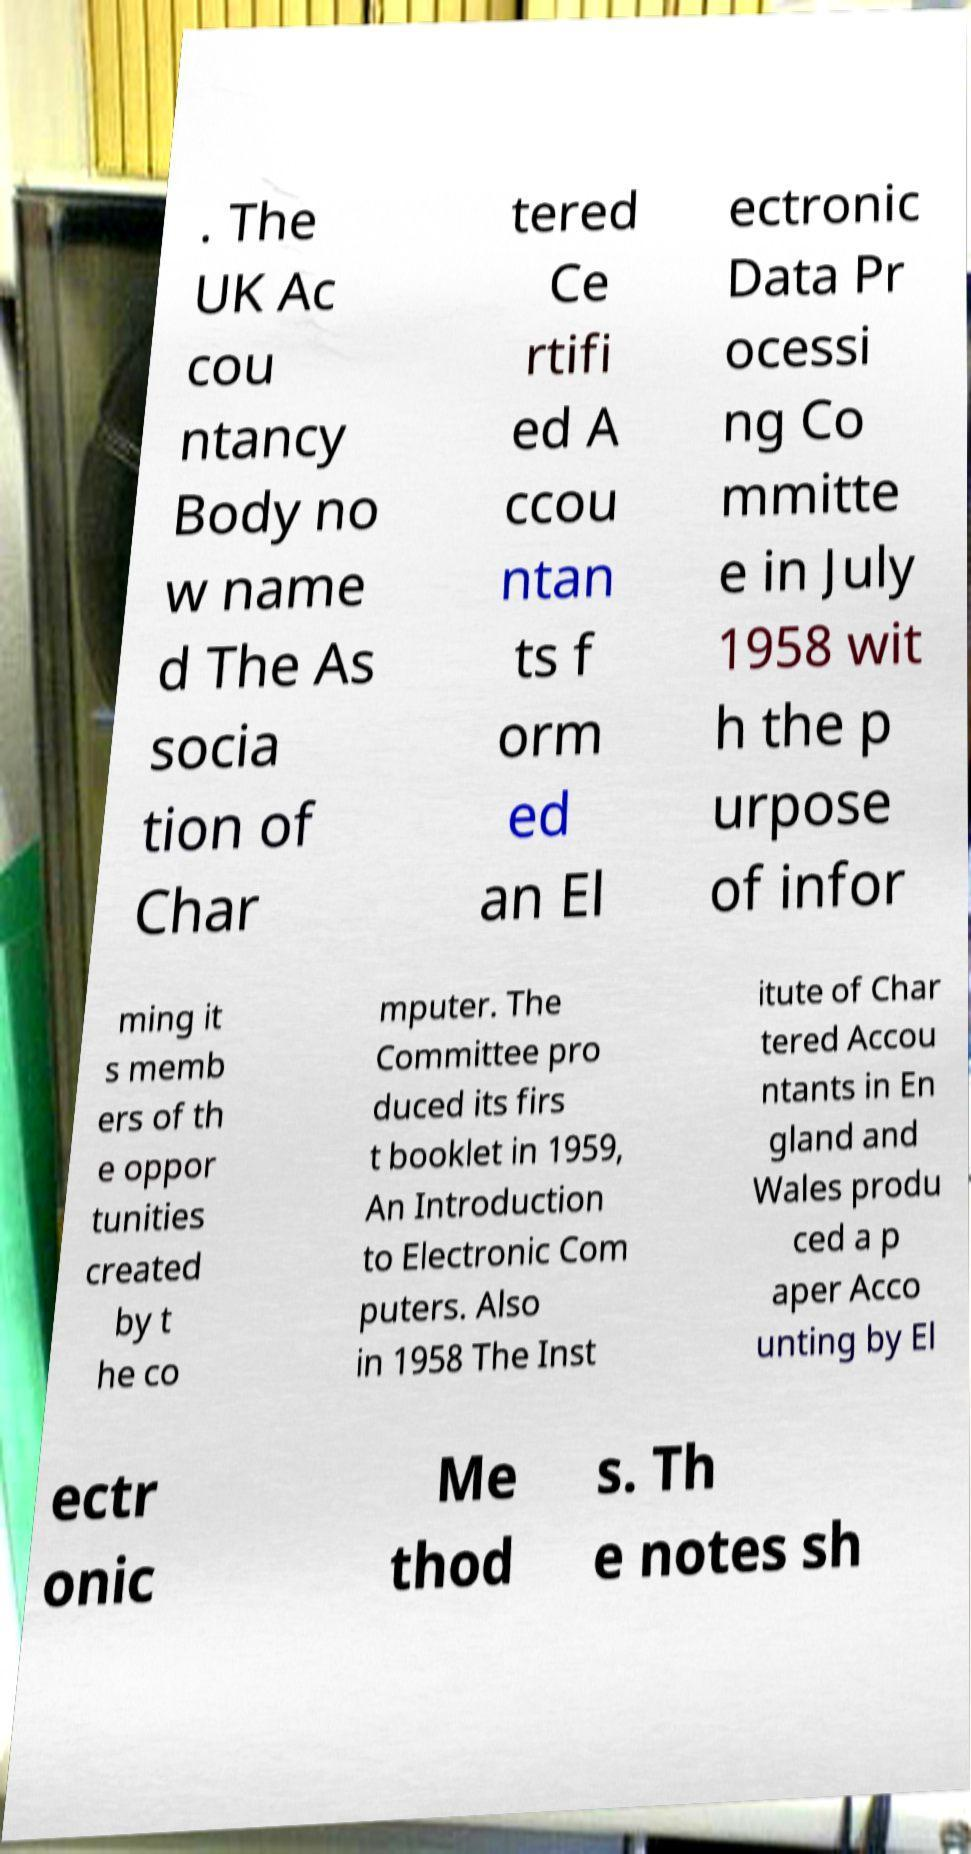For documentation purposes, I need the text within this image transcribed. Could you provide that? . The UK Ac cou ntancy Body no w name d The As socia tion of Char tered Ce rtifi ed A ccou ntan ts f orm ed an El ectronic Data Pr ocessi ng Co mmitte e in July 1958 wit h the p urpose of infor ming it s memb ers of th e oppor tunities created by t he co mputer. The Committee pro duced its firs t booklet in 1959, An Introduction to Electronic Com puters. Also in 1958 The Inst itute of Char tered Accou ntants in En gland and Wales produ ced a p aper Acco unting by El ectr onic Me thod s. Th e notes sh 